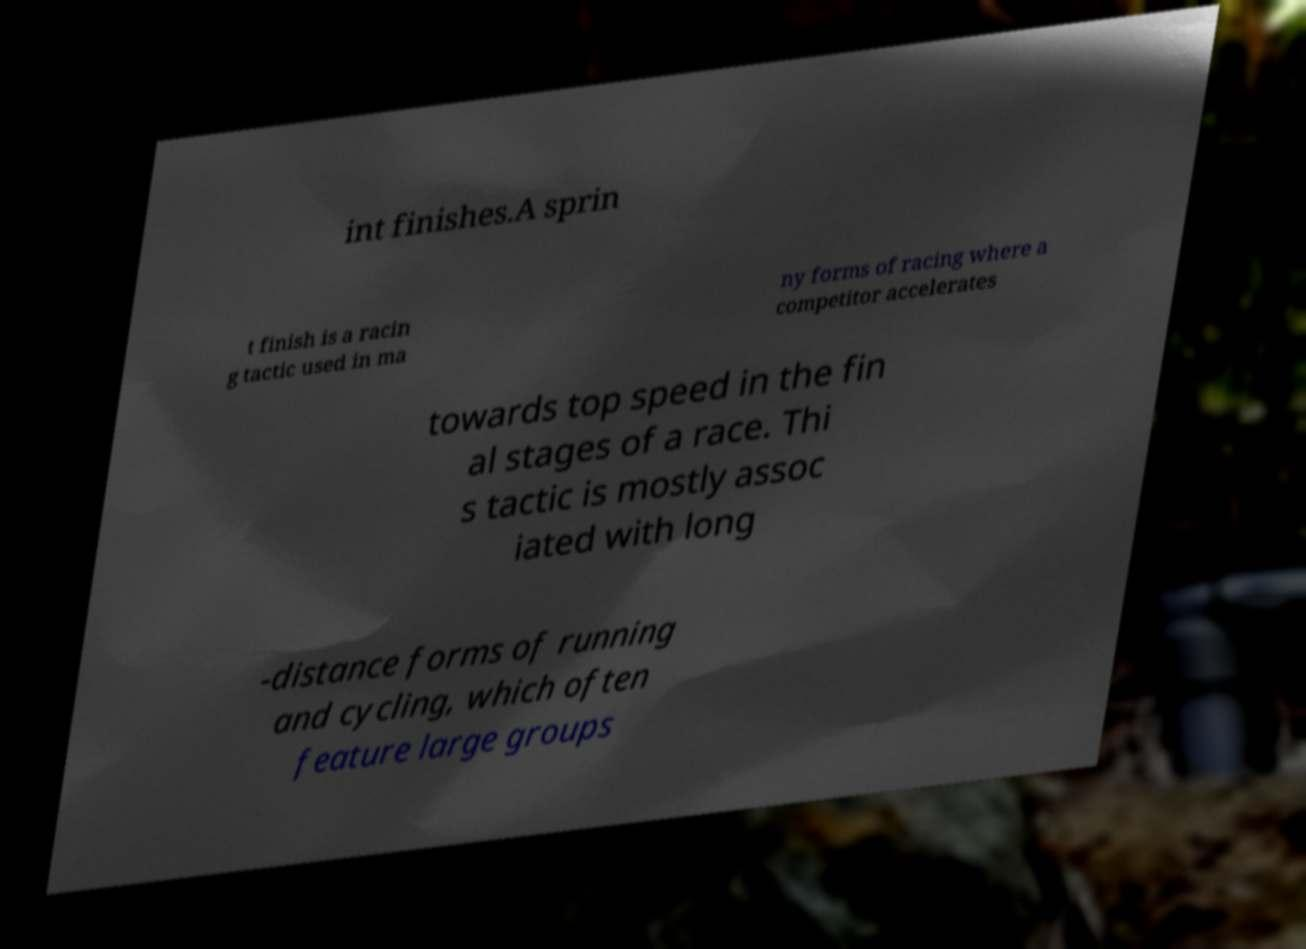Please identify and transcribe the text found in this image. int finishes.A sprin t finish is a racin g tactic used in ma ny forms of racing where a competitor accelerates towards top speed in the fin al stages of a race. Thi s tactic is mostly assoc iated with long -distance forms of running and cycling, which often feature large groups 